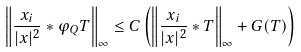<formula> <loc_0><loc_0><loc_500><loc_500>\left \| \frac { x _ { i } } { | x | ^ { 2 } } * \varphi _ { Q } T \right \| _ { \infty } \leq C \left ( \left \| \frac { x _ { i } } { | x | ^ { 2 } } * T \right \| _ { \infty } + G ( T ) \right )</formula> 